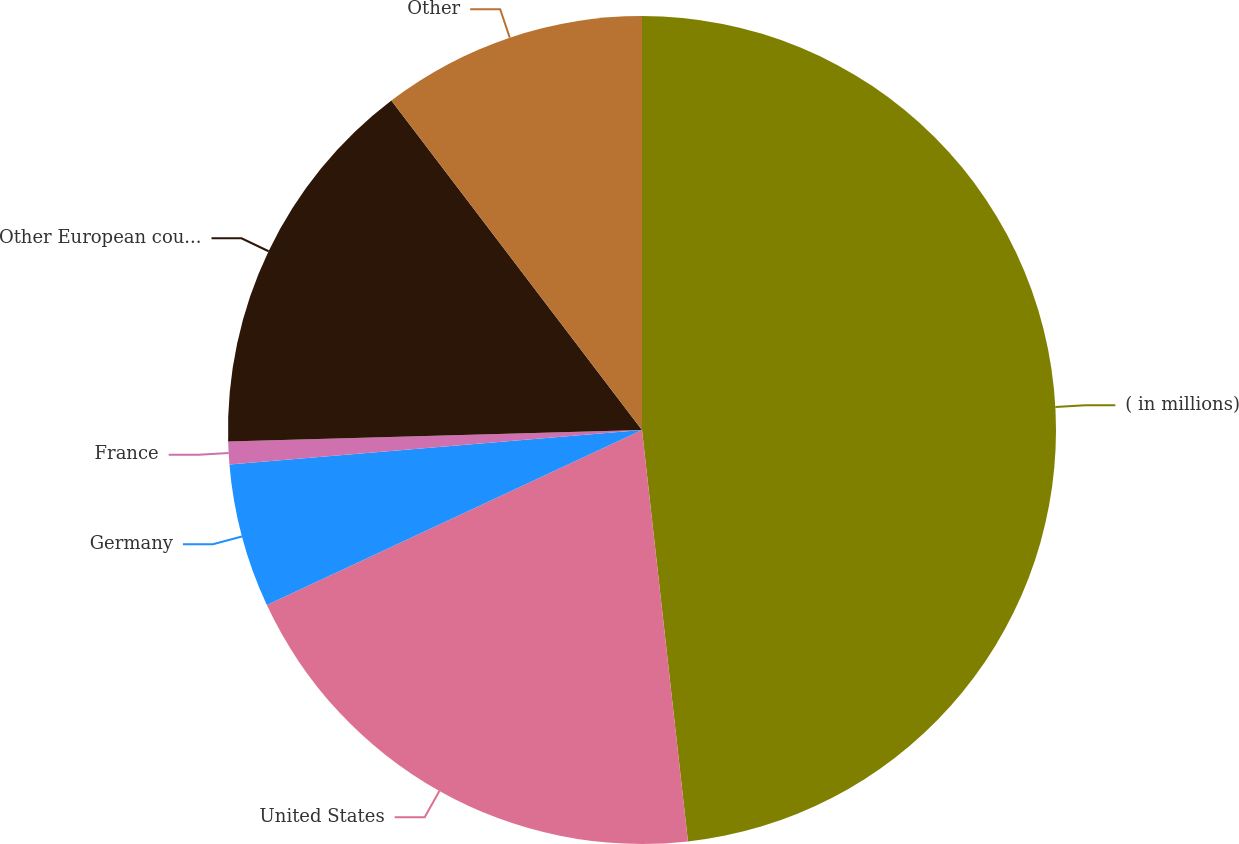<chart> <loc_0><loc_0><loc_500><loc_500><pie_chart><fcel>( in millions)<fcel>United States<fcel>Germany<fcel>France<fcel>Other European countries<fcel>Other<nl><fcel>48.23%<fcel>19.82%<fcel>5.62%<fcel>0.89%<fcel>15.09%<fcel>10.35%<nl></chart> 